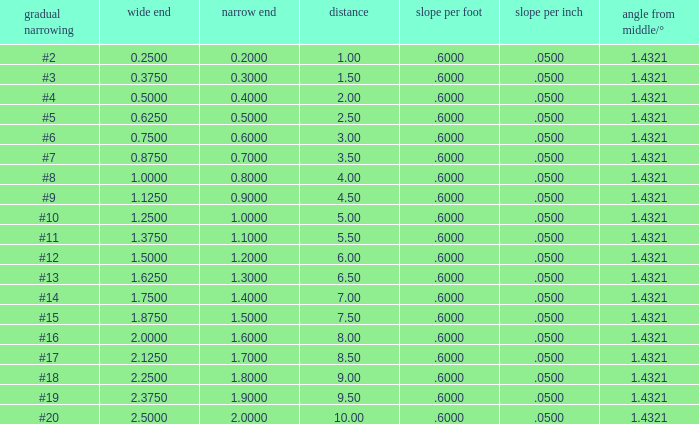Which Length has a Taper of #15, and a Large end larger than 1.875? None. 